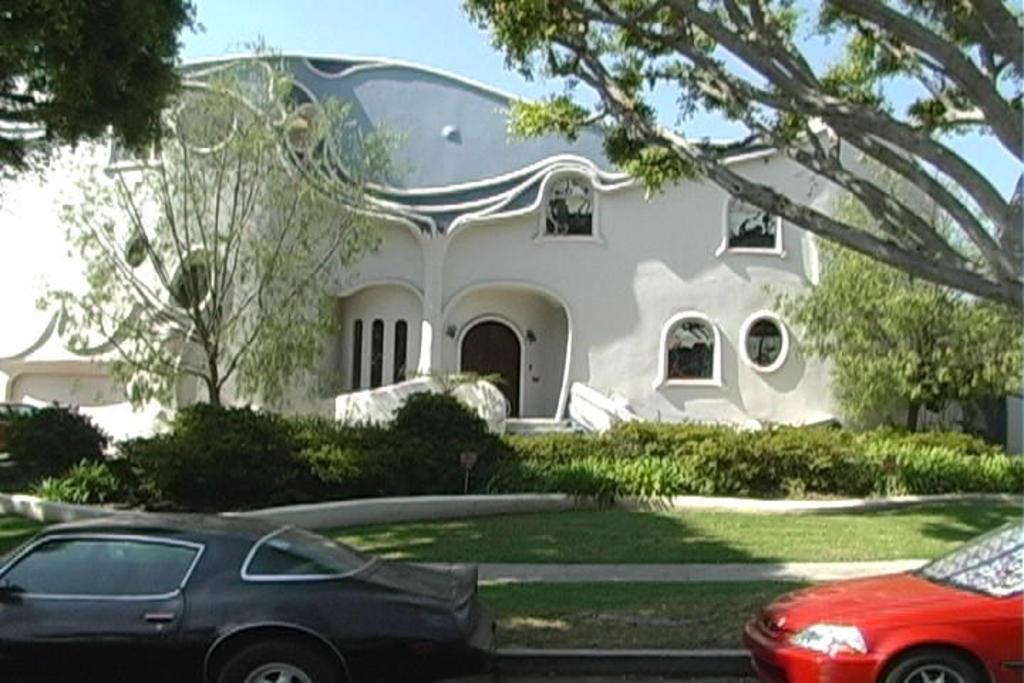Could you give a brief overview of what you see in this image? In this image I can see two cars which are red and black in color. I can see some grass on the ground, few plants, few trees which are green in color and a building which is blue and white in color. In the background I can see the sky. 